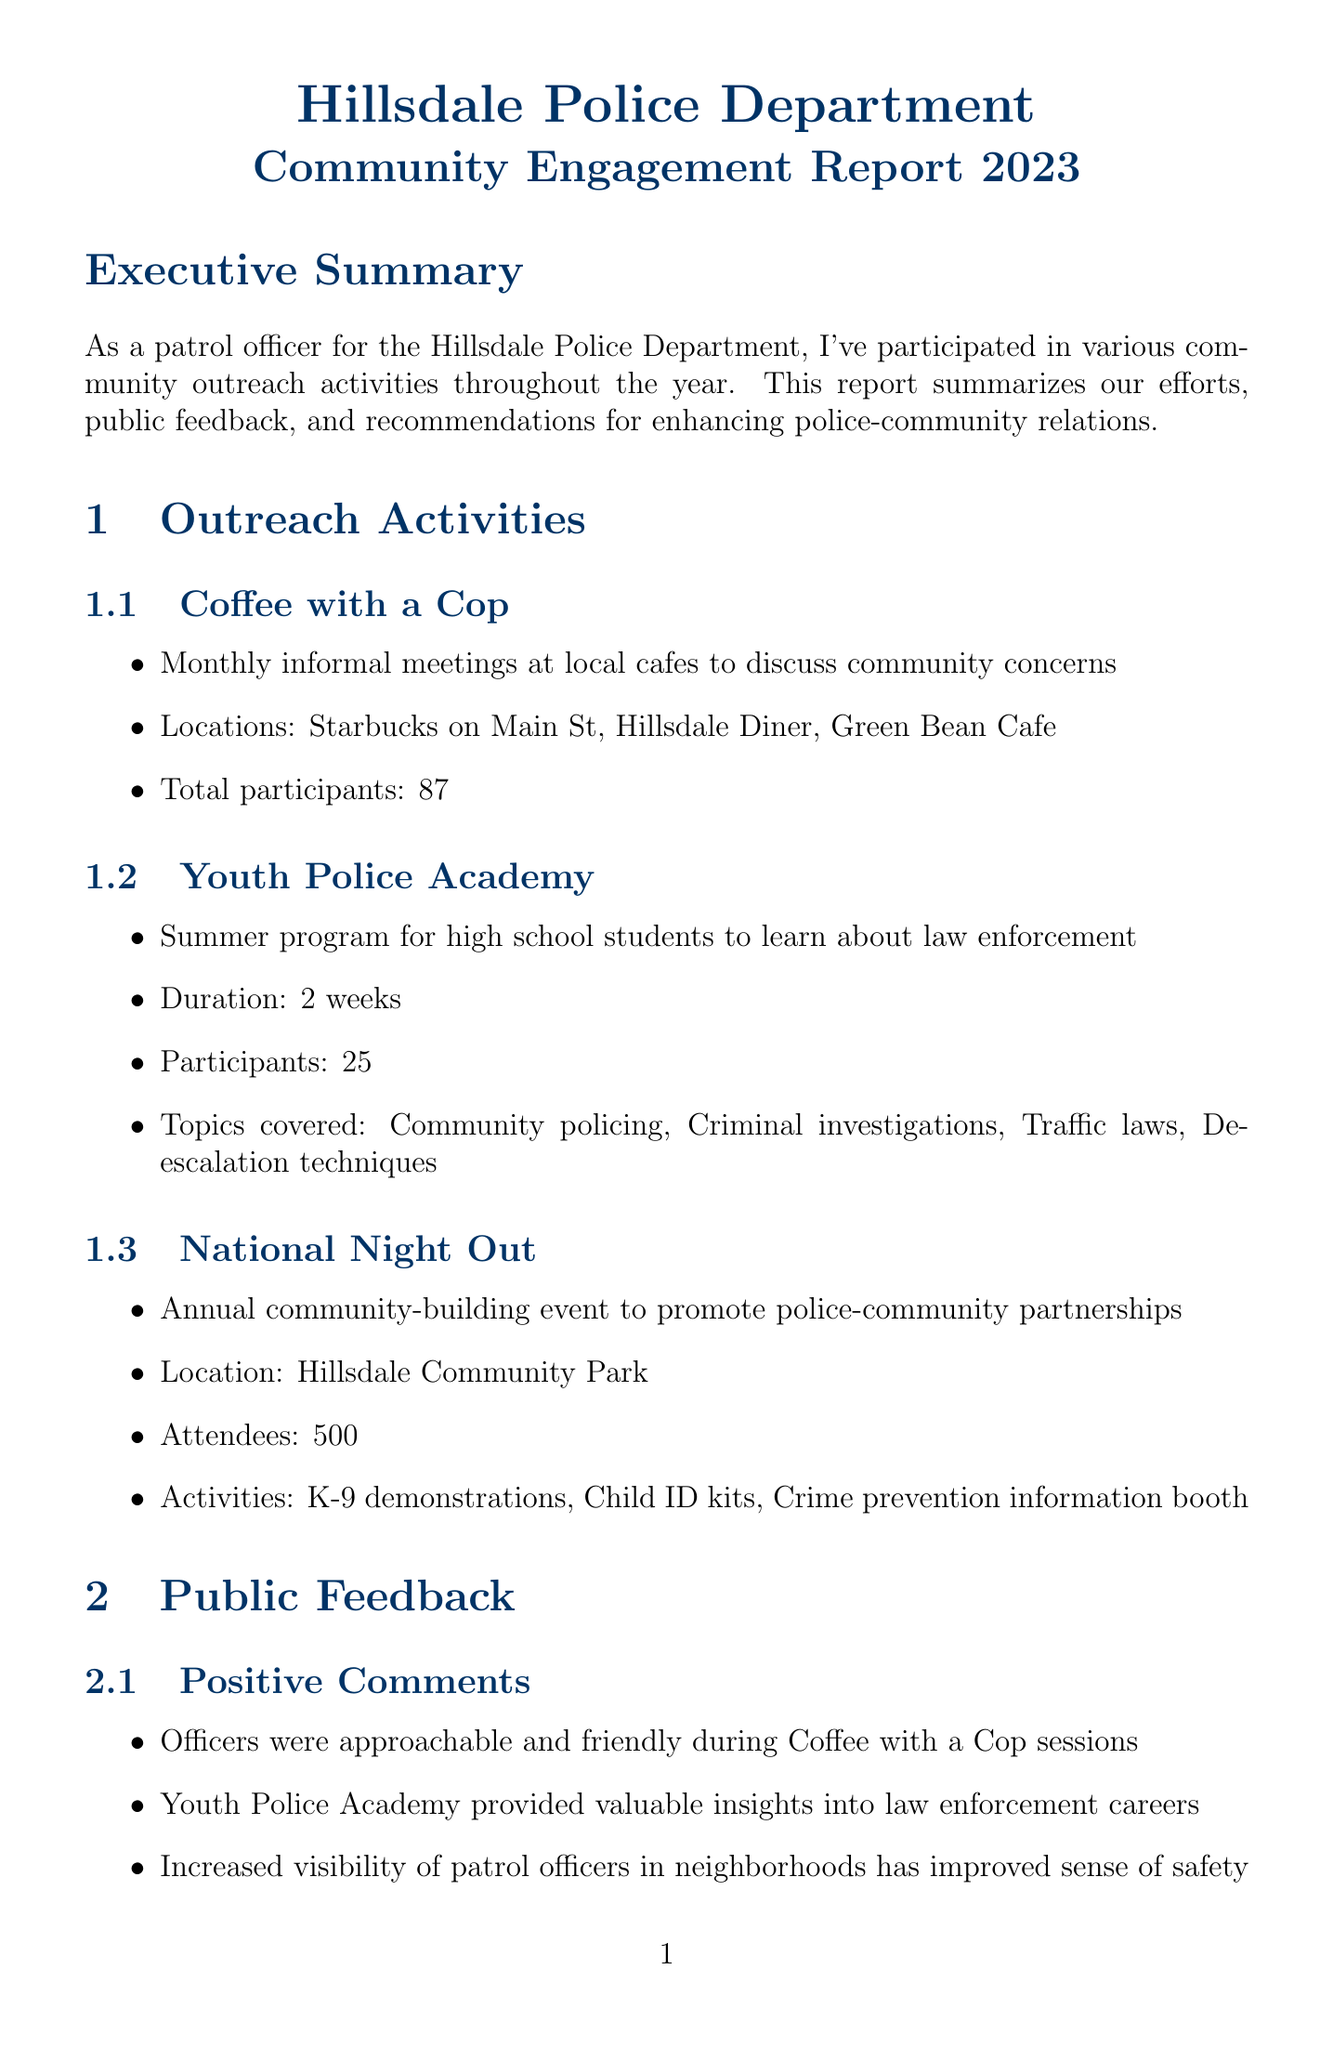what is the title of the report? The title of the report is mentioned in the document header.
Answer: Hillsdale Police Department Community Engagement Report 2023 how many participants attended "Coffee with a Cop"? The report specifies the total number of participants for this outreach activity.
Answer: 87 what is one area for improvement mentioned in the public feedback? The document lists several areas for improvement based on public feedback.
Answer: More frequent updates on crime trends and prevention tips who proposed the "Citizen Police Academy"? The report attributes the proposal of this recommendation to a specific officer.
Answer: Sergeant David Chen what percentage of survey respondents feel safe or very safe in their neighborhood? This metric is indicated in the survey results section of the document.
Answer: 81% what is the location of the "National Night Out" event? The report provides the specific location for this community-building event.
Answer: Hillsdale Community Park how many attendees were there at the "National Night Out"? The document includes attendance information for this event.
Answer: 500 who approved the recommendation to enhance social media presence? The document states who approved various recommendations made by officers.
Answer: Deputy Chief Michael Rodriguez 